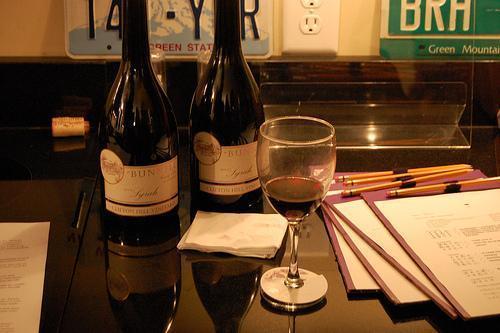How many pencils are in the photo?
Give a very brief answer. 4. How many bottles of wine are there?
Give a very brief answer. 2. How many bottles are on the table?
Give a very brief answer. 2. How many license plates are there?
Give a very brief answer. 2. How many bottles of wine are on the table?
Give a very brief answer. 2. How many wine glasses are on the table?
Give a very brief answer. 1. How many pencils are on the table?
Give a very brief answer. 4. How many outlets are on the wall?
Give a very brief answer. 1. 